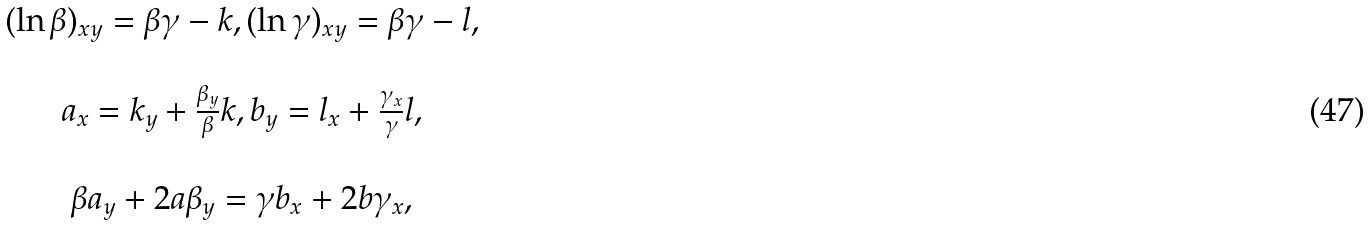<formula> <loc_0><loc_0><loc_500><loc_500>\begin{array} { c } ( \ln \beta ) _ { x y } = \beta \gamma - k , ( \ln \gamma ) _ { x y } = \beta \gamma - l , \\ \ \\ a _ { x } = k _ { y } + \frac { \beta _ { y } } { \beta } k , b _ { y } = l _ { x } + \frac { \gamma _ { x } } { \gamma } l , \\ \ \\ \beta a _ { y } + 2 a \beta _ { y } = \gamma b _ { x } + 2 b \gamma _ { x } , \end{array}</formula> 